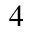<formula> <loc_0><loc_0><loc_500><loc_500>_ { 4 }</formula> 